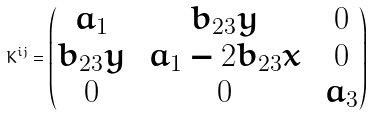Convert formula to latex. <formula><loc_0><loc_0><loc_500><loc_500>K ^ { i j } = \begin{pmatrix} a _ { 1 } \, & b _ { 2 3 } y \, & 0 \\ b _ { 2 3 } y \, & a _ { 1 } - 2 b _ { 2 3 } x \, & 0 \\ 0 \, & 0 \, & a _ { 3 } \end{pmatrix}</formula> 